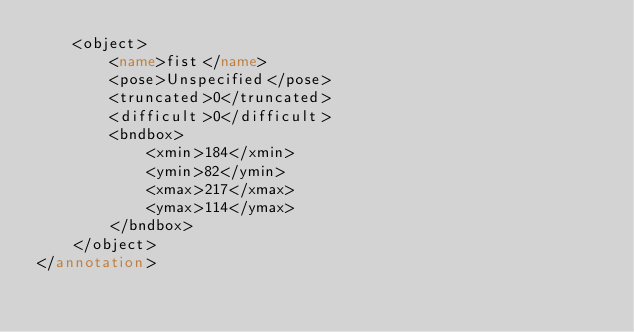Convert code to text. <code><loc_0><loc_0><loc_500><loc_500><_XML_>	<object>
		<name>fist</name>
		<pose>Unspecified</pose>
		<truncated>0</truncated>
		<difficult>0</difficult>
		<bndbox>
			<xmin>184</xmin>
			<ymin>82</ymin>
			<xmax>217</xmax>
			<ymax>114</ymax>
		</bndbox>
	</object>
</annotation>
</code> 